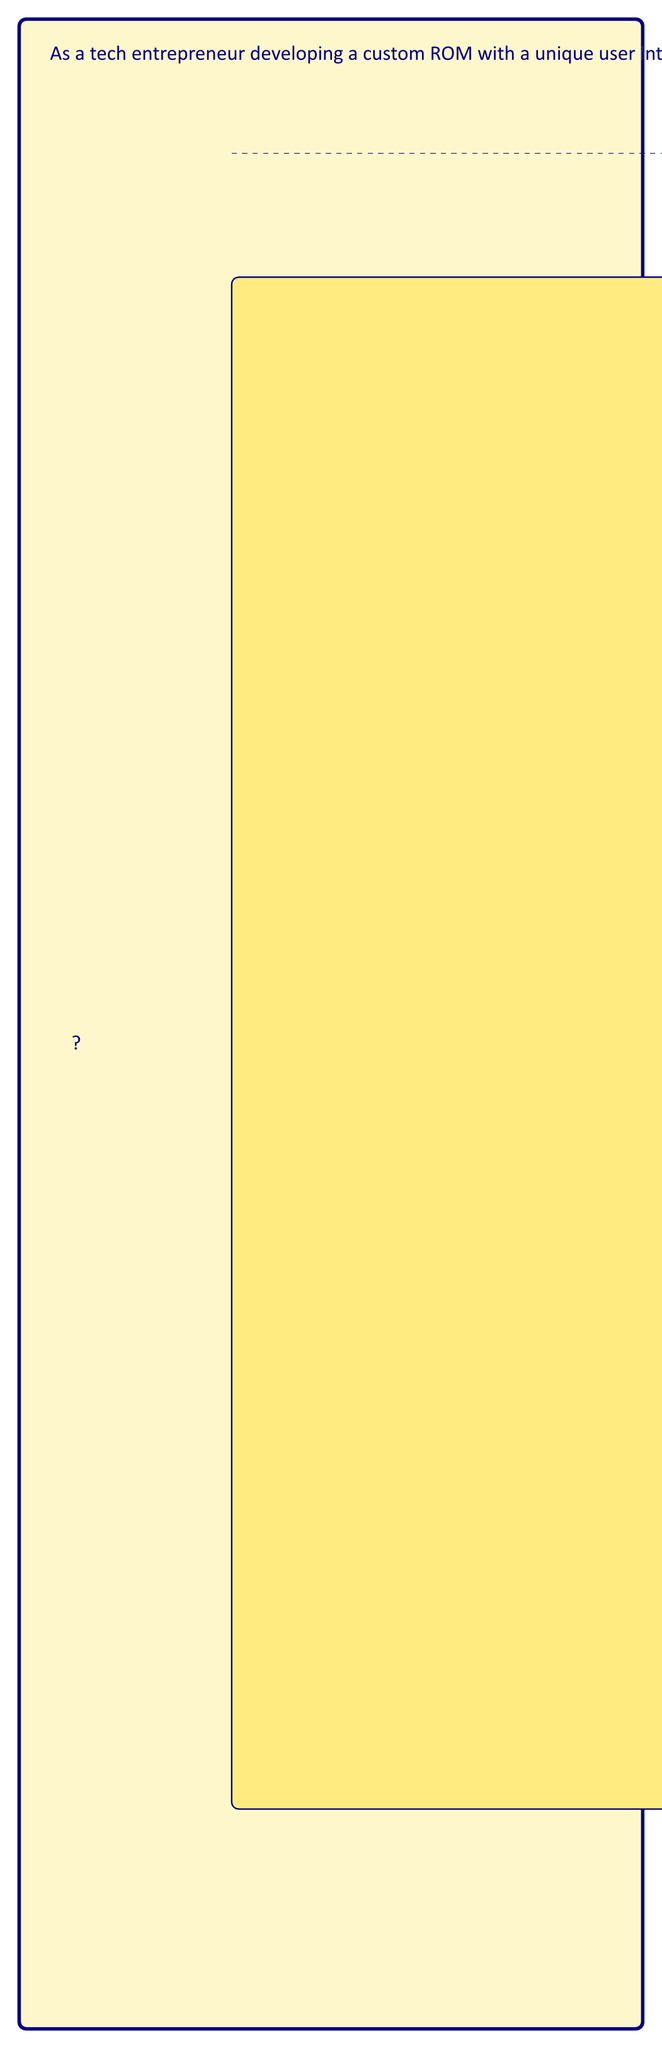Could you help me with this problem? Let's approach this step-by-step:

1) The golden ratio (φ) is defined as:

   $$ \phi = \frac{a+b}{a} = \frac{a}{b} \approx 1.618 $$

   where $a$ is the longer segment and $b$ is the shorter segment.

2) In our case, we know the width (shorter segment) is 100 pixels. Let's call the height $h$. We can set up the equation:

   $$ \frac{h}{100} = \phi $$

3) Solving for $h$:

   $$ h = 100 \times \phi $$

4) We know that $\phi \approx 1.618$, so:

   $$ h = 100 \times 1.618 = 161.8 $$

5) Rounding to the nearest whole pixel:

   $$ h \approx 162 \text{ pixels} $$

Therefore, for a UI element with a width of 100 pixels, its height should be 162 pixels to maintain the golden ratio.
Answer: 162 pixels 